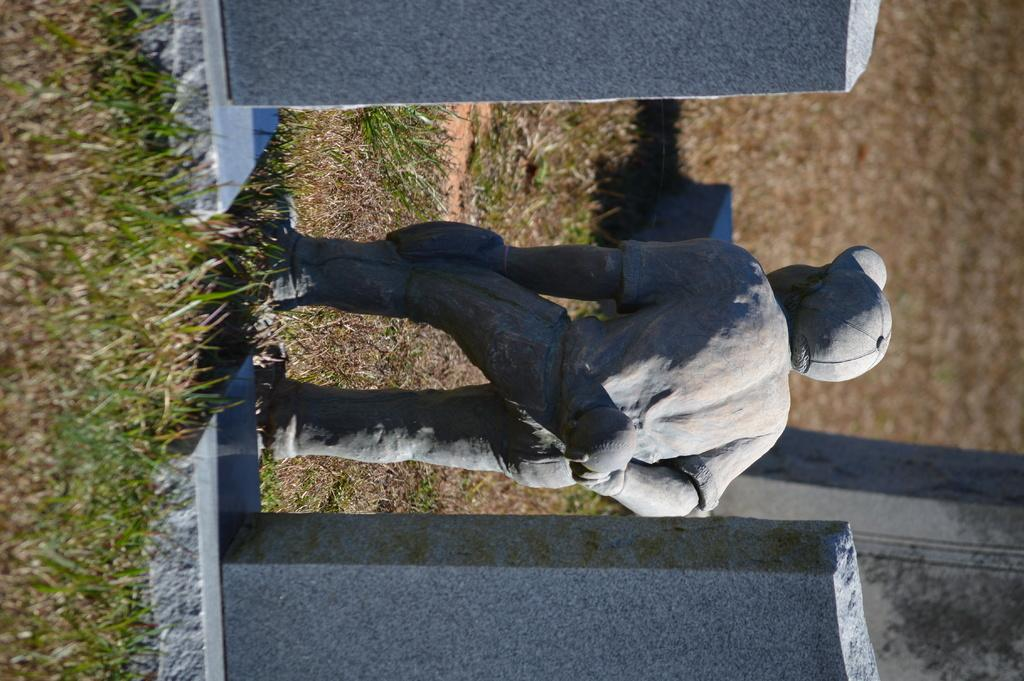What is the main subject in the image? There is a statue in the image. What type of material can be seen around the statue? There are stones in the image. What type of vegetation is present in the image? There is grass in the image. What type of farm animals can be seen on top of the statue in the image? There are no farm animals present in the image, and the statue does not have any animals on top of it. 